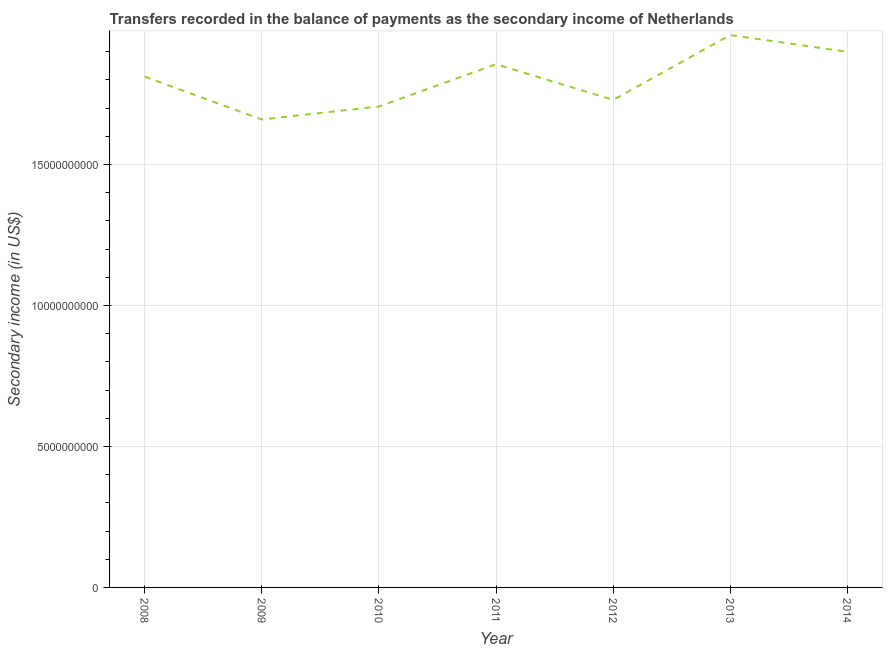What is the amount of secondary income in 2013?
Your answer should be compact. 1.96e+1. Across all years, what is the maximum amount of secondary income?
Make the answer very short. 1.96e+1. Across all years, what is the minimum amount of secondary income?
Offer a very short reply. 1.66e+1. What is the sum of the amount of secondary income?
Your response must be concise. 1.26e+11. What is the difference between the amount of secondary income in 2008 and 2011?
Your answer should be compact. -4.41e+08. What is the average amount of secondary income per year?
Provide a succinct answer. 1.80e+1. What is the median amount of secondary income?
Your response must be concise. 1.81e+1. In how many years, is the amount of secondary income greater than 15000000000 US$?
Your answer should be very brief. 7. What is the ratio of the amount of secondary income in 2012 to that in 2013?
Give a very brief answer. 0.88. Is the amount of secondary income in 2013 less than that in 2014?
Give a very brief answer. No. Is the difference between the amount of secondary income in 2011 and 2012 greater than the difference between any two years?
Provide a short and direct response. No. What is the difference between the highest and the second highest amount of secondary income?
Offer a terse response. 5.96e+08. Is the sum of the amount of secondary income in 2010 and 2012 greater than the maximum amount of secondary income across all years?
Your answer should be compact. Yes. What is the difference between the highest and the lowest amount of secondary income?
Make the answer very short. 3.00e+09. Does the amount of secondary income monotonically increase over the years?
Give a very brief answer. No. How many lines are there?
Your response must be concise. 1. Does the graph contain grids?
Provide a succinct answer. Yes. What is the title of the graph?
Your answer should be compact. Transfers recorded in the balance of payments as the secondary income of Netherlands. What is the label or title of the X-axis?
Offer a very short reply. Year. What is the label or title of the Y-axis?
Offer a very short reply. Secondary income (in US$). What is the Secondary income (in US$) in 2008?
Make the answer very short. 1.81e+1. What is the Secondary income (in US$) in 2009?
Your answer should be very brief. 1.66e+1. What is the Secondary income (in US$) in 2010?
Offer a terse response. 1.71e+1. What is the Secondary income (in US$) in 2011?
Offer a terse response. 1.86e+1. What is the Secondary income (in US$) of 2012?
Your answer should be compact. 1.73e+1. What is the Secondary income (in US$) of 2013?
Make the answer very short. 1.96e+1. What is the Secondary income (in US$) in 2014?
Keep it short and to the point. 1.90e+1. What is the difference between the Secondary income (in US$) in 2008 and 2009?
Provide a short and direct response. 1.52e+09. What is the difference between the Secondary income (in US$) in 2008 and 2010?
Make the answer very short. 1.06e+09. What is the difference between the Secondary income (in US$) in 2008 and 2011?
Offer a very short reply. -4.41e+08. What is the difference between the Secondary income (in US$) in 2008 and 2012?
Give a very brief answer. 8.24e+08. What is the difference between the Secondary income (in US$) in 2008 and 2013?
Offer a terse response. -1.48e+09. What is the difference between the Secondary income (in US$) in 2008 and 2014?
Ensure brevity in your answer.  -8.80e+08. What is the difference between the Secondary income (in US$) in 2009 and 2010?
Make the answer very short. -4.63e+08. What is the difference between the Secondary income (in US$) in 2009 and 2011?
Give a very brief answer. -1.96e+09. What is the difference between the Secondary income (in US$) in 2009 and 2012?
Provide a short and direct response. -6.96e+08. What is the difference between the Secondary income (in US$) in 2009 and 2013?
Offer a terse response. -3.00e+09. What is the difference between the Secondary income (in US$) in 2009 and 2014?
Give a very brief answer. -2.40e+09. What is the difference between the Secondary income (in US$) in 2010 and 2011?
Keep it short and to the point. -1.50e+09. What is the difference between the Secondary income (in US$) in 2010 and 2012?
Ensure brevity in your answer.  -2.33e+08. What is the difference between the Secondary income (in US$) in 2010 and 2013?
Your answer should be compact. -2.53e+09. What is the difference between the Secondary income (in US$) in 2010 and 2014?
Offer a terse response. -1.94e+09. What is the difference between the Secondary income (in US$) in 2011 and 2012?
Ensure brevity in your answer.  1.27e+09. What is the difference between the Secondary income (in US$) in 2011 and 2013?
Offer a terse response. -1.03e+09. What is the difference between the Secondary income (in US$) in 2011 and 2014?
Keep it short and to the point. -4.39e+08. What is the difference between the Secondary income (in US$) in 2012 and 2013?
Your response must be concise. -2.30e+09. What is the difference between the Secondary income (in US$) in 2012 and 2014?
Keep it short and to the point. -1.70e+09. What is the difference between the Secondary income (in US$) in 2013 and 2014?
Your response must be concise. 5.96e+08. What is the ratio of the Secondary income (in US$) in 2008 to that in 2009?
Give a very brief answer. 1.09. What is the ratio of the Secondary income (in US$) in 2008 to that in 2010?
Offer a terse response. 1.06. What is the ratio of the Secondary income (in US$) in 2008 to that in 2011?
Offer a terse response. 0.98. What is the ratio of the Secondary income (in US$) in 2008 to that in 2012?
Your response must be concise. 1.05. What is the ratio of the Secondary income (in US$) in 2008 to that in 2013?
Your response must be concise. 0.93. What is the ratio of the Secondary income (in US$) in 2008 to that in 2014?
Provide a short and direct response. 0.95. What is the ratio of the Secondary income (in US$) in 2009 to that in 2010?
Make the answer very short. 0.97. What is the ratio of the Secondary income (in US$) in 2009 to that in 2011?
Your response must be concise. 0.89. What is the ratio of the Secondary income (in US$) in 2009 to that in 2012?
Your response must be concise. 0.96. What is the ratio of the Secondary income (in US$) in 2009 to that in 2013?
Make the answer very short. 0.85. What is the ratio of the Secondary income (in US$) in 2009 to that in 2014?
Ensure brevity in your answer.  0.87. What is the ratio of the Secondary income (in US$) in 2010 to that in 2011?
Your answer should be compact. 0.92. What is the ratio of the Secondary income (in US$) in 2010 to that in 2012?
Your answer should be very brief. 0.99. What is the ratio of the Secondary income (in US$) in 2010 to that in 2013?
Offer a very short reply. 0.87. What is the ratio of the Secondary income (in US$) in 2010 to that in 2014?
Your answer should be very brief. 0.9. What is the ratio of the Secondary income (in US$) in 2011 to that in 2012?
Make the answer very short. 1.07. What is the ratio of the Secondary income (in US$) in 2011 to that in 2013?
Provide a succinct answer. 0.95. What is the ratio of the Secondary income (in US$) in 2012 to that in 2013?
Give a very brief answer. 0.88. What is the ratio of the Secondary income (in US$) in 2012 to that in 2014?
Your answer should be very brief. 0.91. What is the ratio of the Secondary income (in US$) in 2013 to that in 2014?
Your response must be concise. 1.03. 